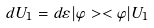<formula> <loc_0><loc_0><loc_500><loc_500>d U _ { 1 } = d \varepsilon | \varphi > < \varphi | U _ { 1 }</formula> 